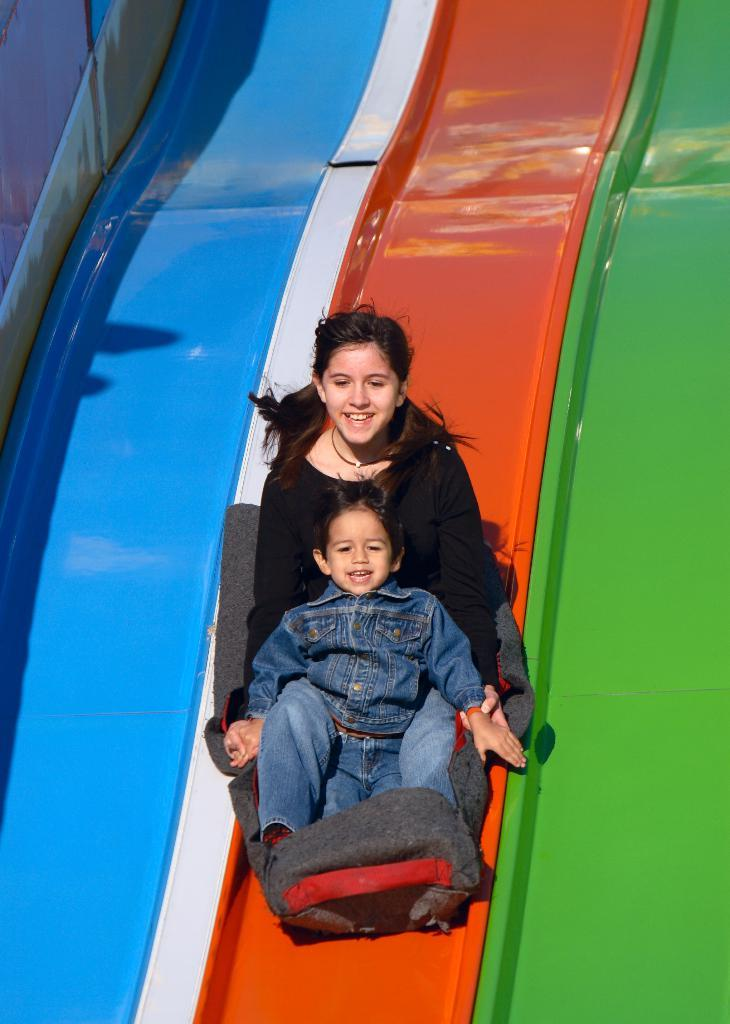Who can be seen in the image? There is a girl and a boy in the image. What are the girl and boy doing in the image? The girl and boy are sitting on a float chair. What can be seen in the background of the image? There are slides visible in the background of the image. What type of jam is being served on the lamp in the image? There is no jam or lamp present in the image. What kind of jewel is the girl wearing in the image? There is no mention of any jewelry in the image; the girl and boy are simply sitting on a float chair. 